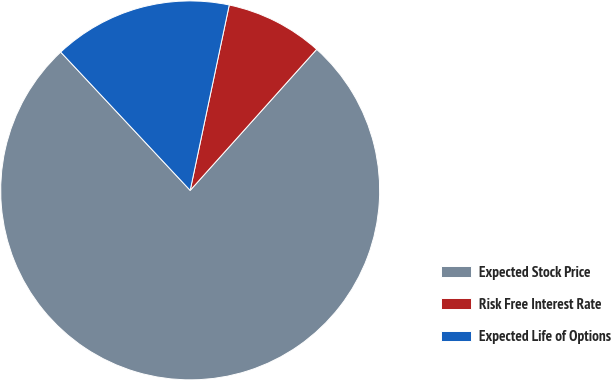Convert chart. <chart><loc_0><loc_0><loc_500><loc_500><pie_chart><fcel>Expected Stock Price<fcel>Risk Free Interest Rate<fcel>Expected Life of Options<nl><fcel>76.39%<fcel>8.33%<fcel>15.28%<nl></chart> 